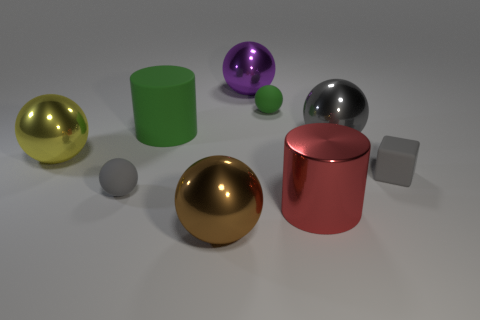How does the lighting in this image affect the appearance of the objects? The lighting in this image creates a soft reflection and subtle shadows on the objects, which enhances their three-dimensional form and metallic texture. It also generates highlights that suggest a calm, diffuse light source, contributing to the overall serene and uncluttered ambiance of the scene. 